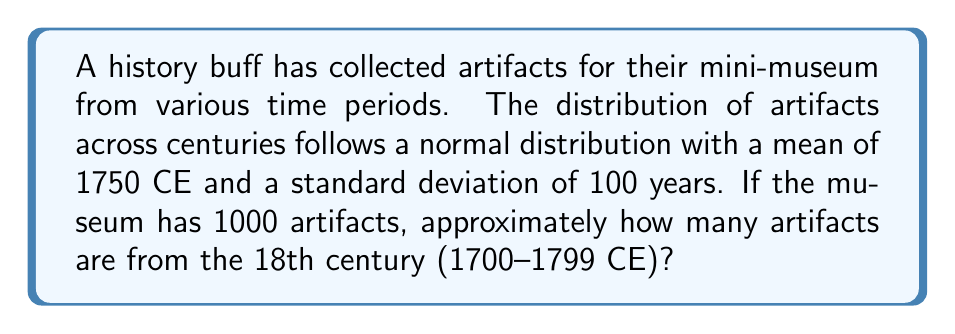Can you solve this math problem? To solve this problem, we need to use the properties of the normal distribution and the z-score formula.

Step 1: Calculate the z-scores for the boundaries of the 18th century.
For 1700 CE: $z_1 = \frac{1700 - 1750}{100} = -0.5$
For 1799 CE: $z_2 = \frac{1799 - 1750}{100} = 0.49$

Step 2: Find the area under the standard normal curve between these z-scores.
Using a standard normal table or calculator:
$P(-0.5 < Z < 0.49) = P(Z < 0.49) - P(Z < -0.5)$
$= 0.6879 - 0.3085 = 0.3794$

Step 3: Calculate the number of artifacts from the 18th century.
Number of artifacts = Total artifacts × Probability
$= 1000 \times 0.3794 = 379.4$

Step 4: Round to the nearest whole number, as we can't have a fractional artifact.
Approximately 379 artifacts are from the 18th century.
Answer: 379 artifacts 